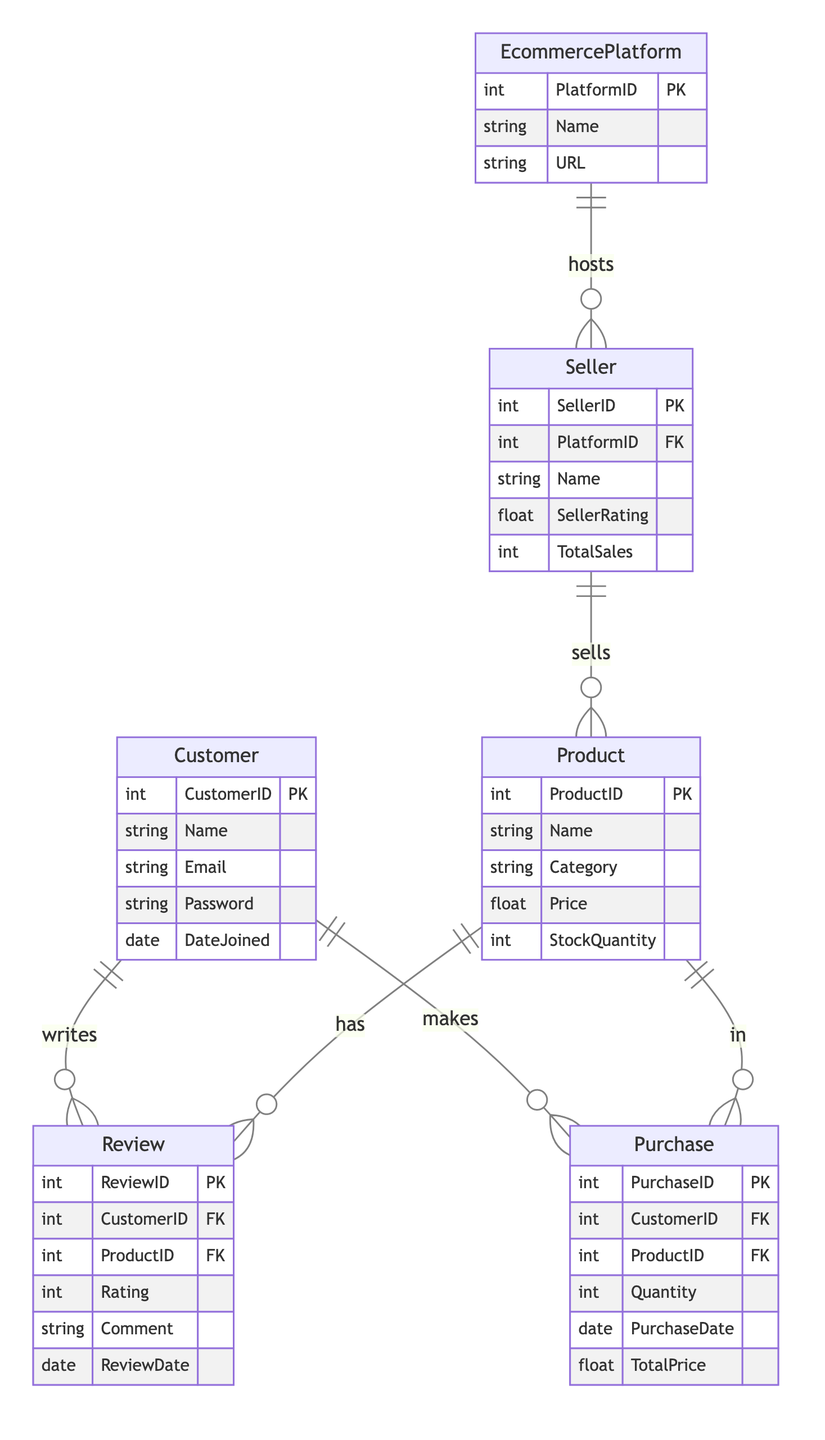What is the primary key of the Customer entity? The primary key of the Customer entity is CustomerID, as indicated by "int CustomerID PK" in the diagram.
Answer: CustomerID How many entities are present in the diagram? The diagram contains six entities: Customer, Product, Review, Purchase, EcommercePlatform, and Seller. This can be counted directly from the entities section.
Answer: 6 What does the Seller entity reference in the diagram? The Seller entity references the EcommercePlatform through the PlatformID foreign key, as shown by "int PlatformID FK" in the Seller entity.
Answer: EcommercePlatform How many attributes does the Review entity have? The Review entity has six attributes: ReviewID, CustomerID, ProductID, Rating, Comment, and ReviewDate, as listed under the Review section.
Answer: 6 What is the cardinality of the Customer writing a Review? The cardinality of the relationship where a Customer writes a Review is one-to-many, denoted by "1:N" in the diagram.
Answer: One-to-many Which entity's attributes include SellerRating? The Seller entity includes the attribute SellerRating, explicitly mentioned in the Seller section as "float SellerRating."
Answer: Seller 